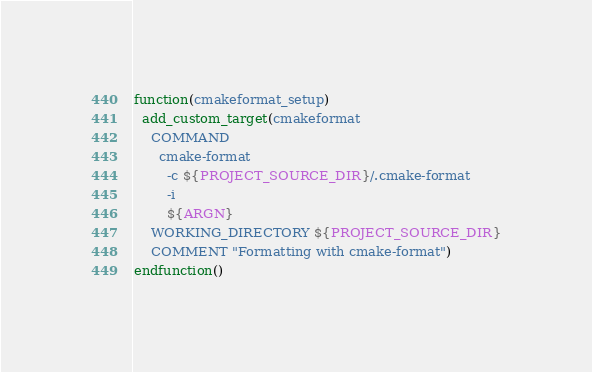<code> <loc_0><loc_0><loc_500><loc_500><_CMake_>function(cmakeformat_setup)
  add_custom_target(cmakeformat
    COMMAND
      cmake-format
        -c ${PROJECT_SOURCE_DIR}/.cmake-format
        -i
        ${ARGN}
    WORKING_DIRECTORY ${PROJECT_SOURCE_DIR}
    COMMENT "Formatting with cmake-format")
endfunction()
</code> 